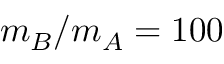Convert formula to latex. <formula><loc_0><loc_0><loc_500><loc_500>m _ { B } / m _ { A } = 1 0 0</formula> 